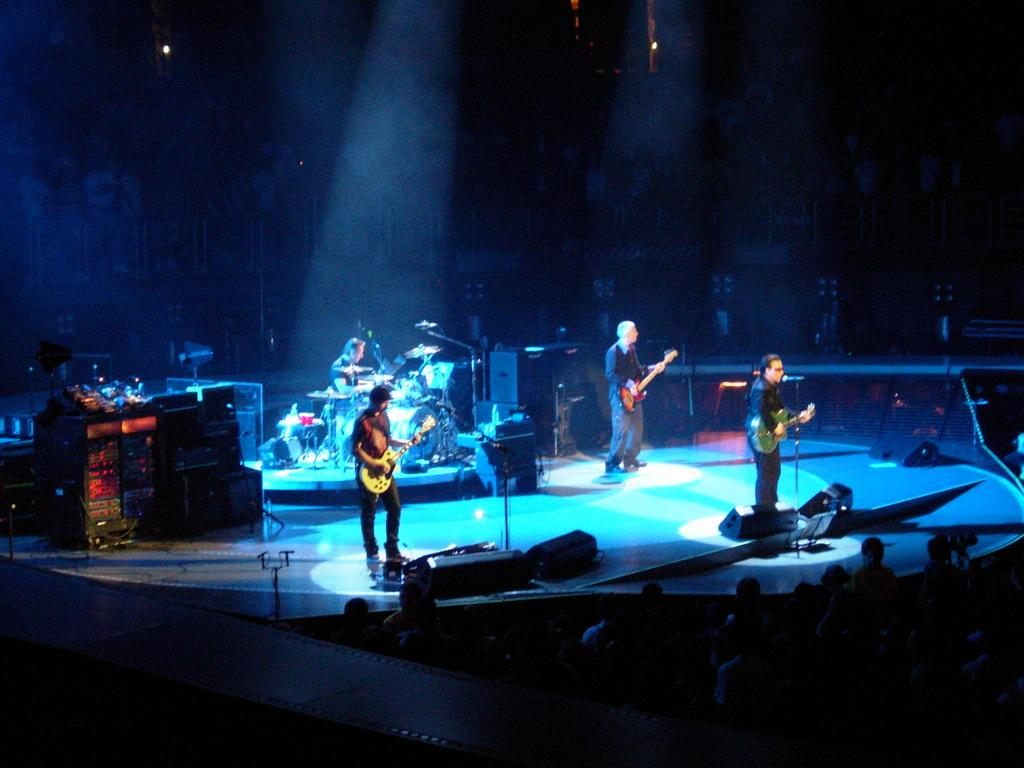What are the people in the image doing? The people in the image are holding guitars. Is there anyone else in the image besides the people holding guitars? Yes, there is a man sitting in the image. What is the man sitting in the image doing? The man is playing drums. What color is the shirt of the snail in the image? There are no snails present in the image, and therefore no shirts to describe. 